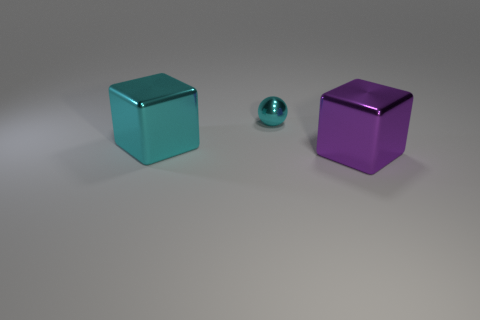Add 2 blue shiny blocks. How many objects exist? 5 Subtract 1 balls. How many balls are left? 0 Subtract all blocks. How many objects are left? 1 Subtract all gray blocks. Subtract all yellow cylinders. How many blocks are left? 2 Subtract all cyan cubes. How many purple balls are left? 0 Subtract all big cyan metal blocks. Subtract all metallic spheres. How many objects are left? 1 Add 1 small shiny spheres. How many small shiny spheres are left? 2 Add 1 tiny gray objects. How many tiny gray objects exist? 1 Subtract 0 green cylinders. How many objects are left? 3 